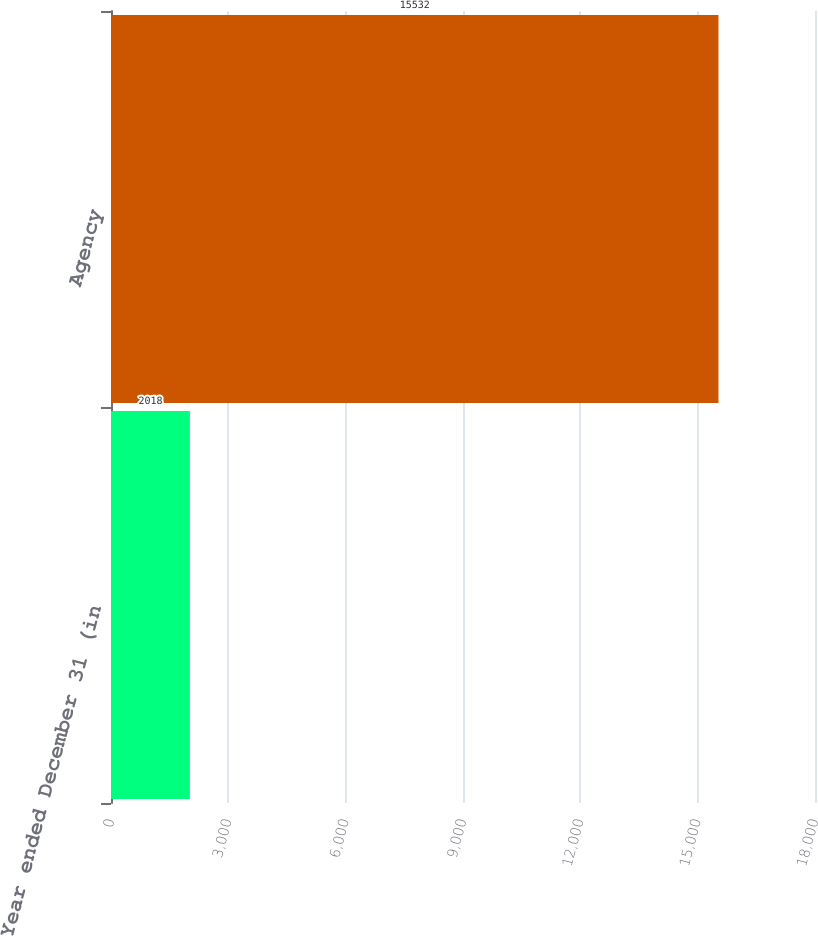Convert chart to OTSL. <chart><loc_0><loc_0><loc_500><loc_500><bar_chart><fcel>Year ended December 31 (in<fcel>Agency<nl><fcel>2018<fcel>15532<nl></chart> 